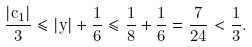Convert formula to latex. <formula><loc_0><loc_0><loc_500><loc_500>\frac { | c _ { 1 } | } { 3 } \leq | y | + \frac { 1 } { 6 } \leq \frac { 1 } { 8 } + \frac { 1 } { 6 } = \frac { 7 } { 2 4 } < \frac { 1 } { 3 } .</formula> 